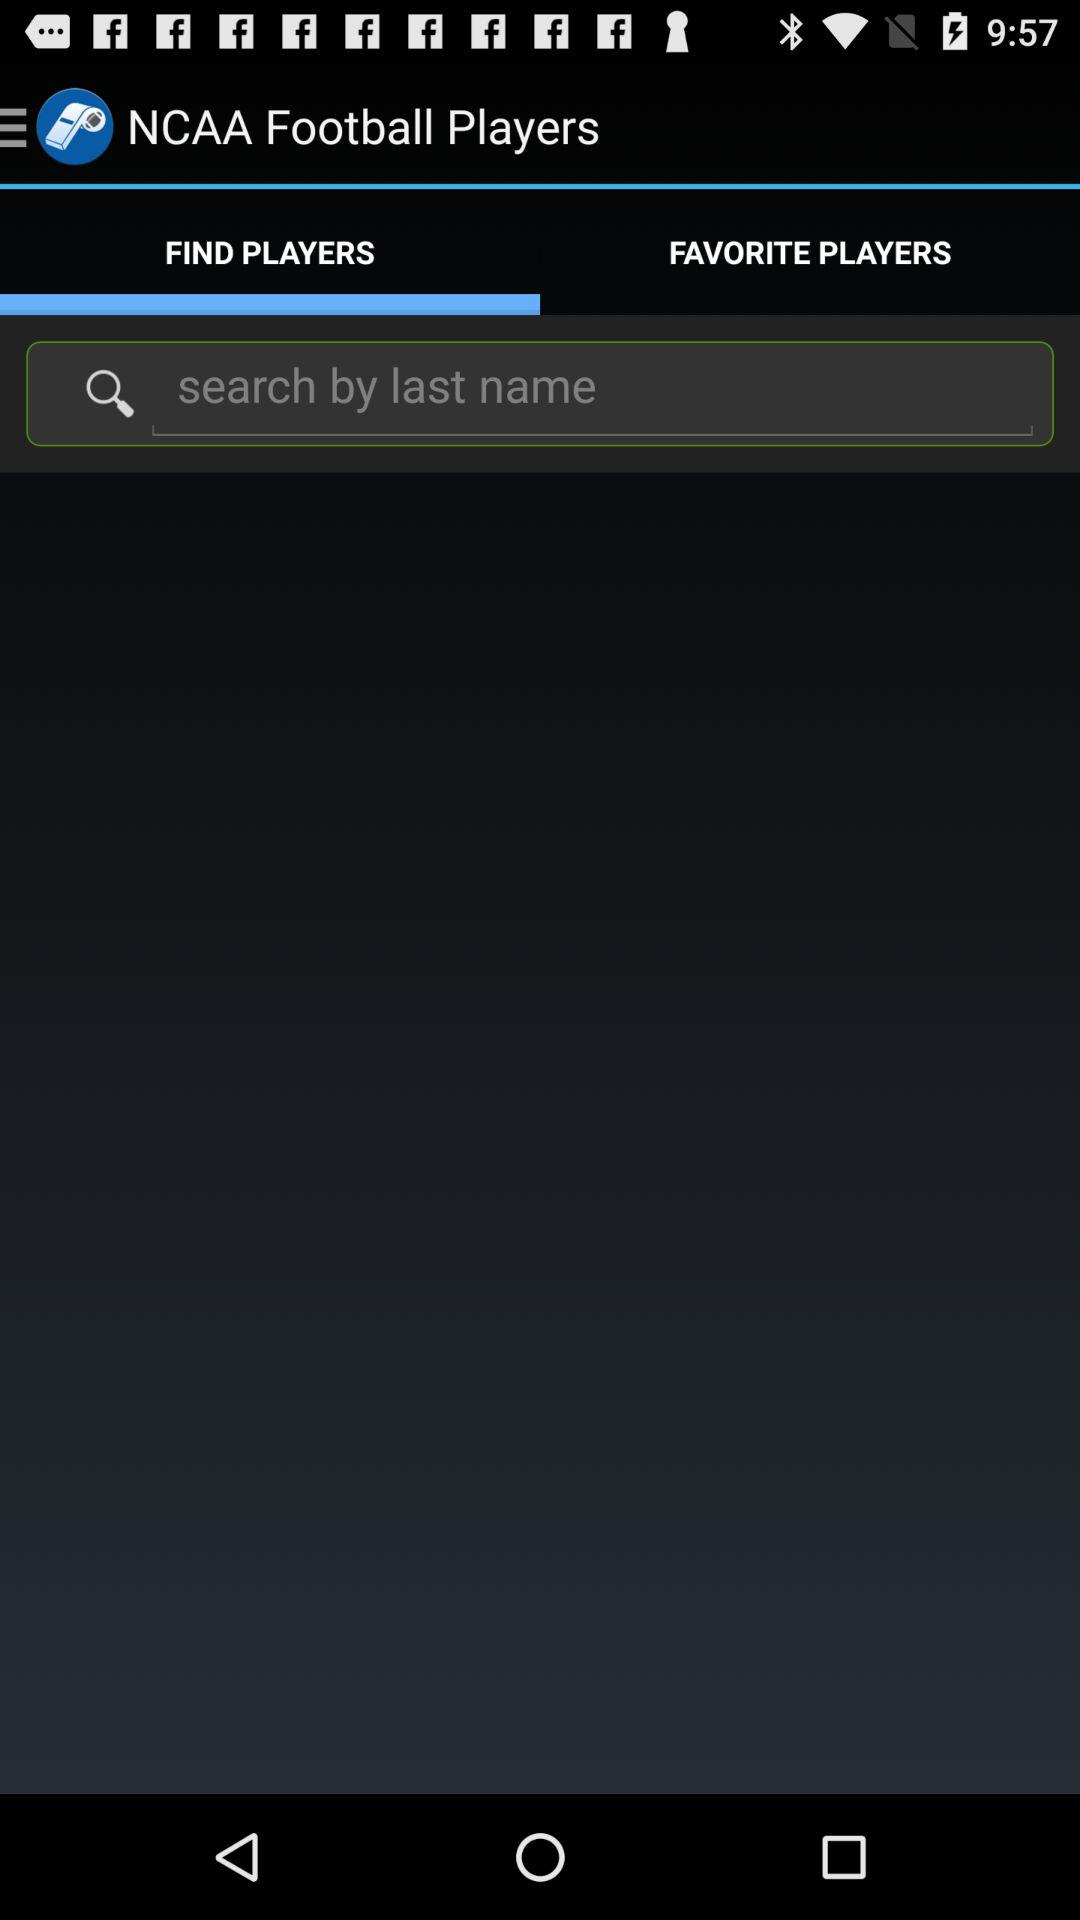Which tab has been selected? The selected tab is "FIND PLAYERS". 